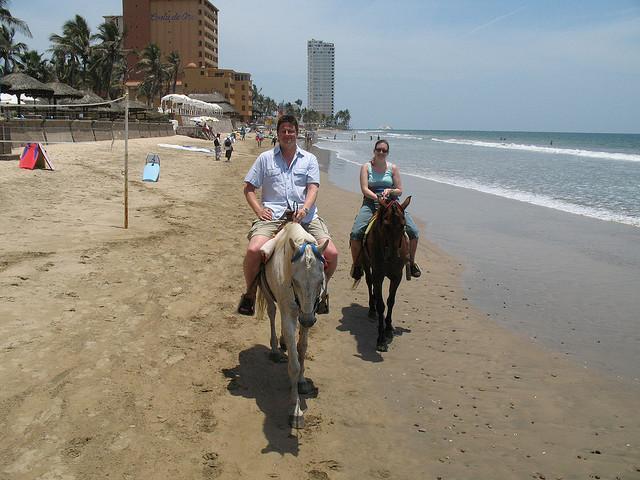How many people can you see?
Give a very brief answer. 2. 